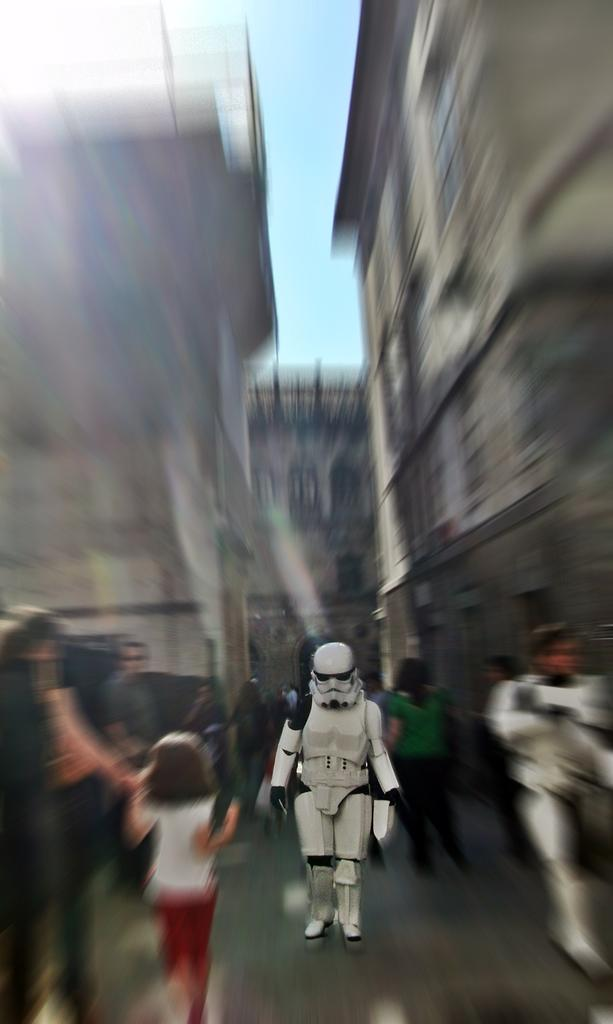What is the main subject in the middle of the picture? There is a robot in the middle of the picture. How would you describe the overall clarity of the image? The picture is blurred. What can be seen in the background of the image? There are buildings in the background of the image. Where are the people located in the image? There are people towards the left side of the image. How many ladybugs can be seen on the robot in the image? There are no ladybugs present in the image, as it features a robot and not insects. 